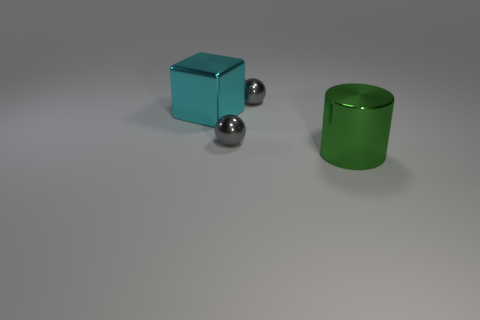There is a small sphere in front of the shiny sphere behind the big metal cube; what color is it?
Provide a short and direct response. Gray. There is a tiny gray metal sphere that is behind the big shiny object that is behind the metal cylinder; is there a object to the left of it?
Provide a succinct answer. Yes. Do the cyan thing and the large thing in front of the big cube have the same shape?
Offer a very short reply. No. There is a tiny thing that is in front of the metal cube; is its color the same as the object that is behind the big cyan object?
Make the answer very short. Yes. Are any shiny blocks visible?
Offer a terse response. Yes. Are there any big green objects that have the same material as the cyan cube?
Make the answer very short. Yes. What color is the big cylinder?
Give a very brief answer. Green. What is the color of the metallic cube that is the same size as the green cylinder?
Your response must be concise. Cyan. What number of metallic objects are green objects or large cyan things?
Make the answer very short. 2. How many shiny objects are to the left of the big cylinder and on the right side of the cyan block?
Your answer should be compact. 2. 